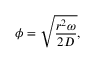Convert formula to latex. <formula><loc_0><loc_0><loc_500><loc_500>\phi = \sqrt { \frac { r ^ { 2 } \omega } { 2 D } } ,</formula> 